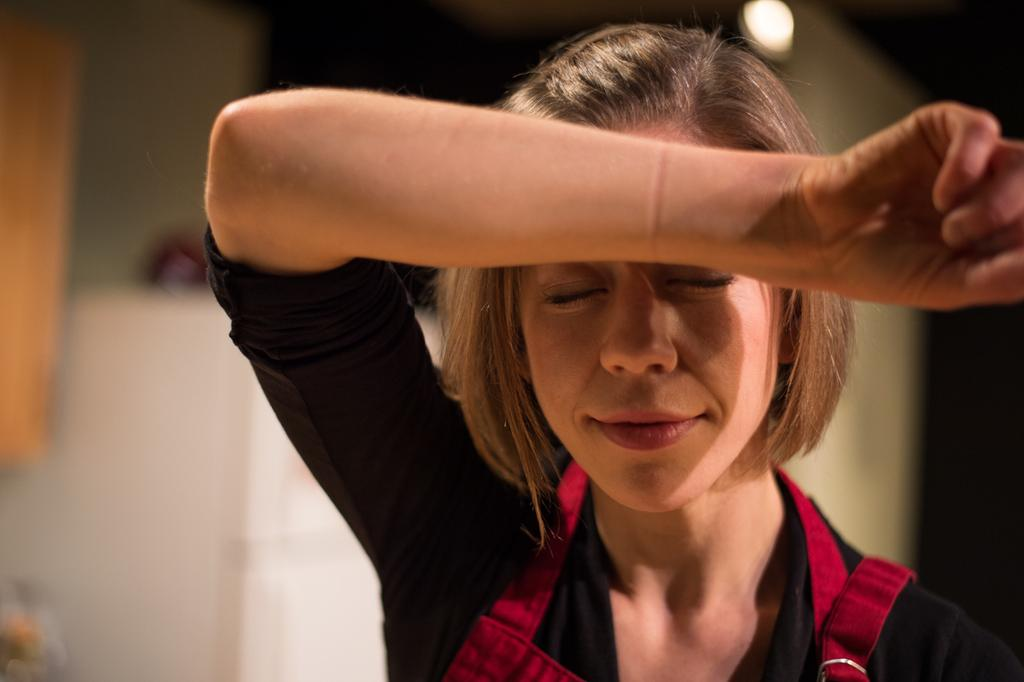Who is present in the image? There is a woman in the image. What is the woman's facial expression? The woman is smiling. Can you describe the lighting in the image? There is light in the image. How would you describe the background of the image? The background of the image is blurry. How long does it take for the dirt to accumulate in the image? There is no dirt present in the image, so it cannot be determined how long it would take for it to accumulate. 